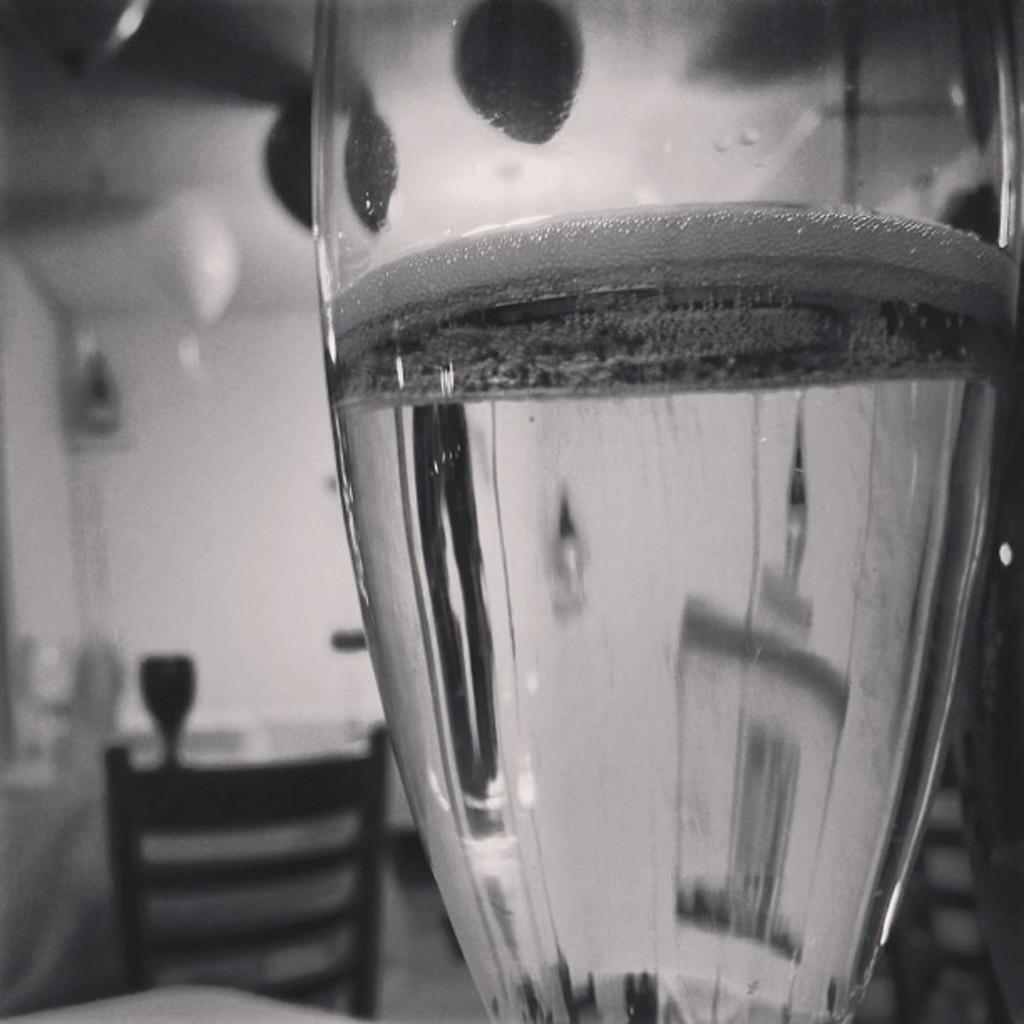Please provide a concise description of this image. In this picture we can see a glass with water in it, chair and some objects and in the background it is blurry. 